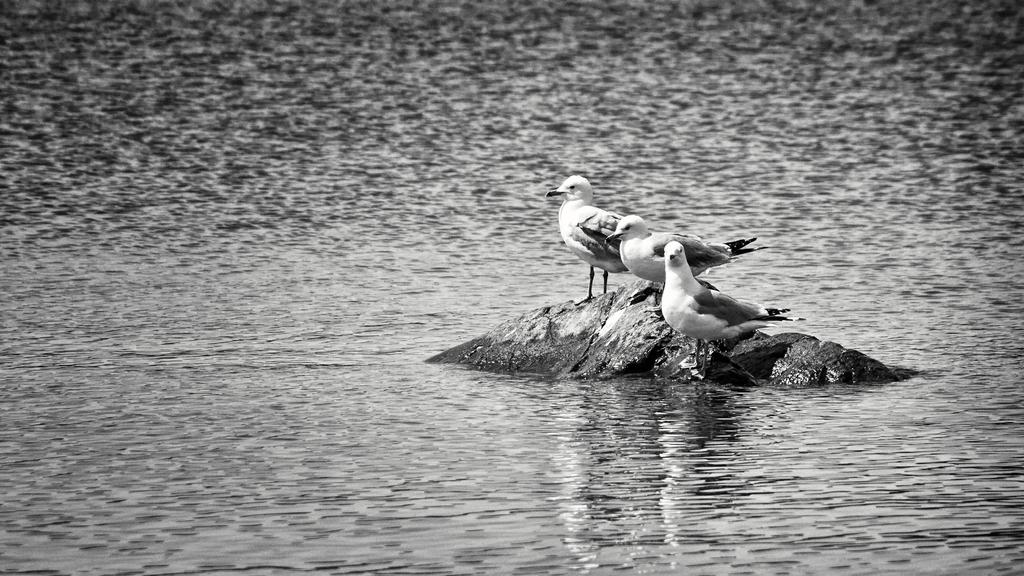What type of animals can be seen in the image? There are birds in the image. Where are the birds located? The birds are on a stone in the image. What is the stone situated on? The stone is in the middle of water. What can be seen in the background of the image? There is water visible in the background of the image. What type of desk can be seen in the image? There is no desk present in the image; it features birds on a stone in the middle of water. 